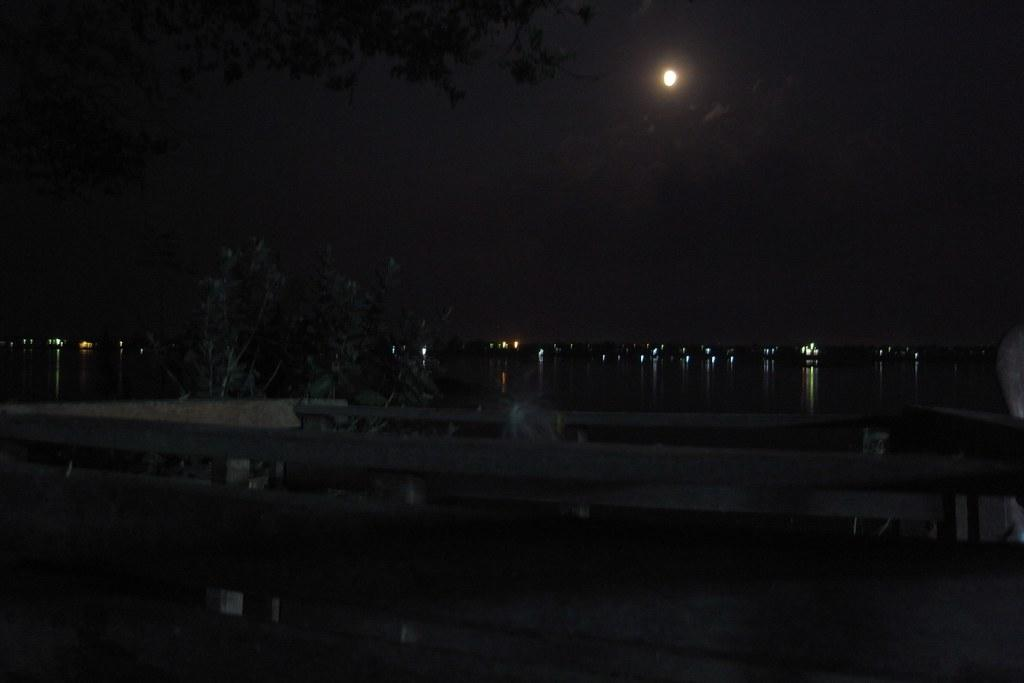What type of natural feature can be seen in the image? There is a river in the image. What man-made structure is present in the image? There is fencing in the image. What can be seen in the background of the image? Lights and the sky are visible in the background. What celestial body is present in the sky? There is a moon in the sky. What type of baseball equipment can be seen in the image? There is no baseball equipment present in the image. Can you describe the walkway in the image? There is no walkway mentioned in the provided facts, so we cannot describe it. 